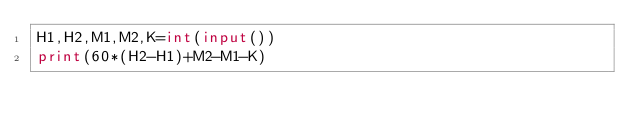<code> <loc_0><loc_0><loc_500><loc_500><_Python_>H1,H2,M1,M2,K=int(input()) 
print(60*(H2-H1)+M2-M1-K)
</code> 